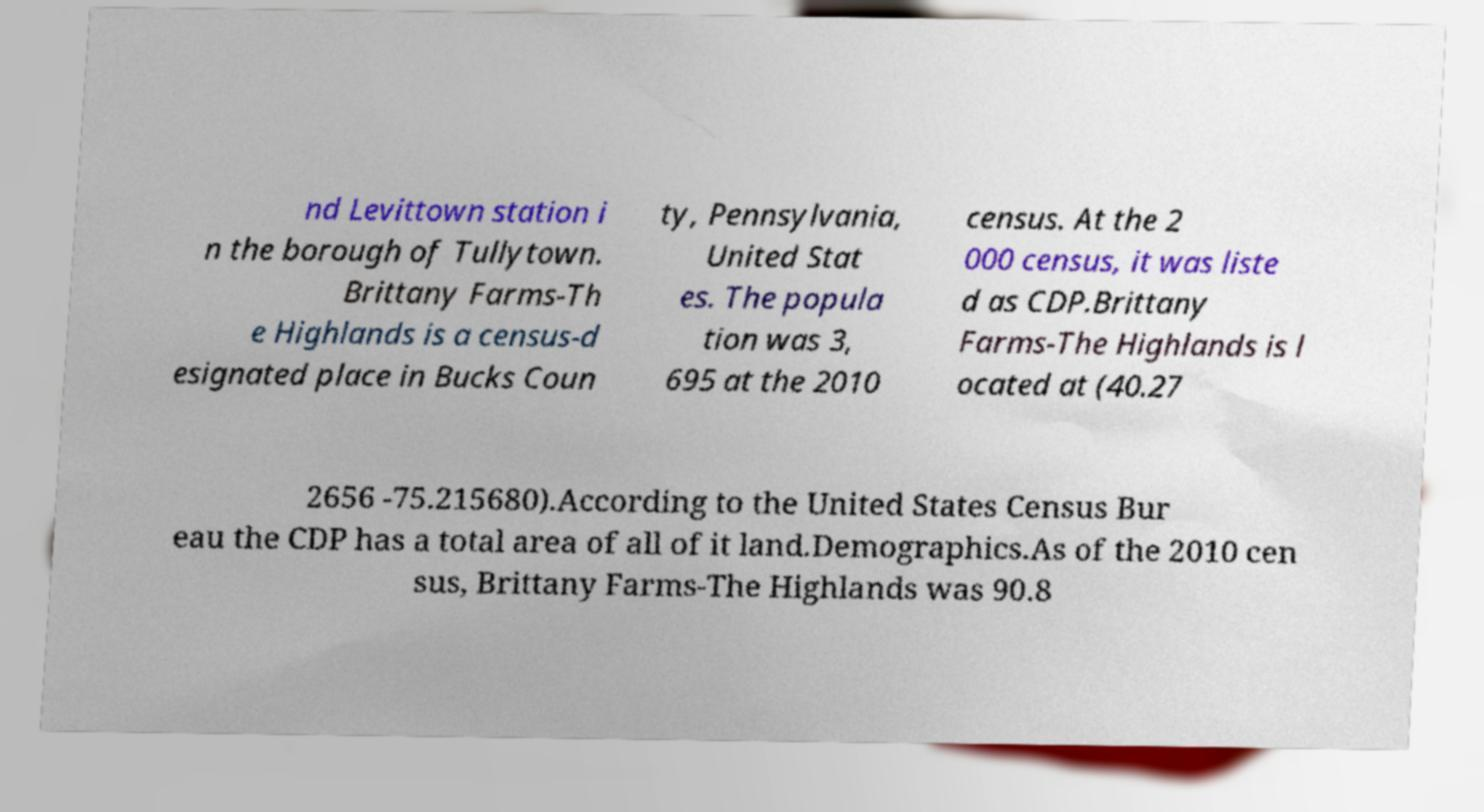Could you assist in decoding the text presented in this image and type it out clearly? nd Levittown station i n the borough of Tullytown. Brittany Farms-Th e Highlands is a census-d esignated place in Bucks Coun ty, Pennsylvania, United Stat es. The popula tion was 3, 695 at the 2010 census. At the 2 000 census, it was liste d as CDP.Brittany Farms-The Highlands is l ocated at (40.27 2656 -75.215680).According to the United States Census Bur eau the CDP has a total area of all of it land.Demographics.As of the 2010 cen sus, Brittany Farms-The Highlands was 90.8 